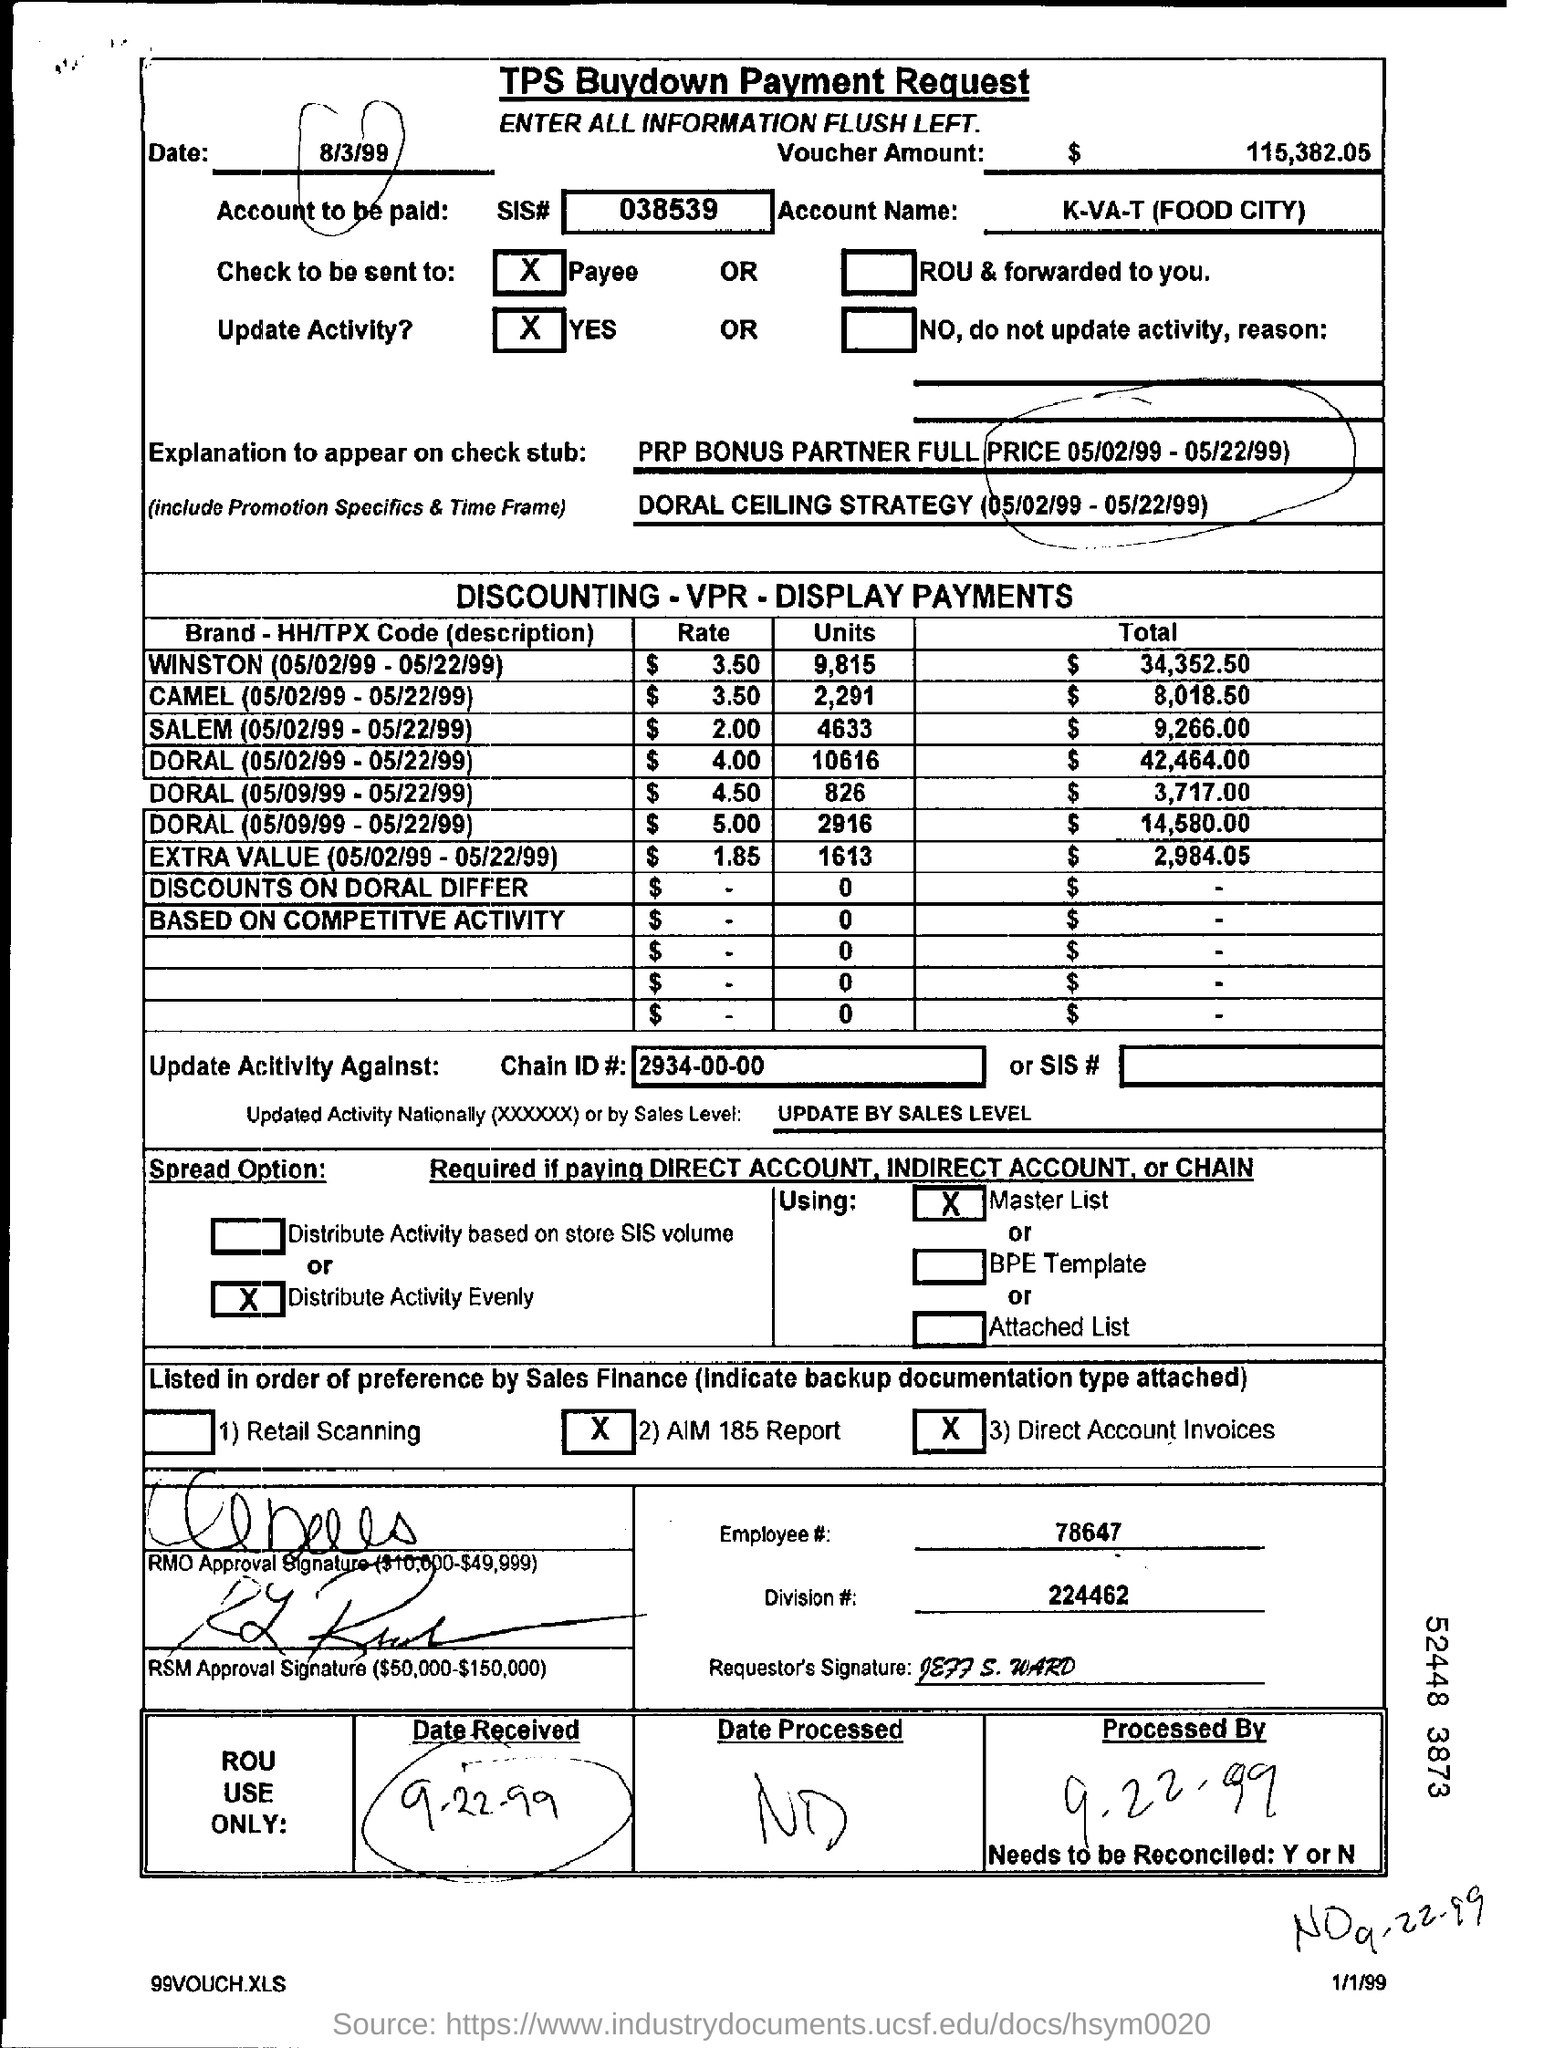What is the SIS #?
Your answer should be compact. 038539. What is the Voucher Amount?
Your answer should be compact. $115,382.05. What is the Account Name?
Offer a very short reply. K-VA-T (Food City). What is the Total for Winston (05/02/99 - 05/22/99)?
Offer a terse response. $34352.50. What is the Total for Camel (05/02/99 - 05/22/99)?
Make the answer very short. $8018.50. What is the Total for Salem (05/02/99 - 05/22/99)?
Offer a terse response. $9,266.00. What is the Chain ID #?
Provide a succinct answer. 2934-00-00. What is the Employee #?
Provide a succinct answer. 78647. What is the Division #?
Make the answer very short. 224462. 